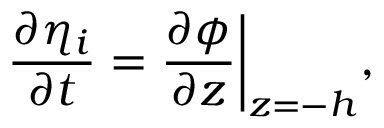<formula> <loc_0><loc_0><loc_500><loc_500>\frac { \partial \eta _ { i } } { \partial t } = \frac { \partial \phi } { \partial z } \Big | _ { z = - h } ,</formula> 